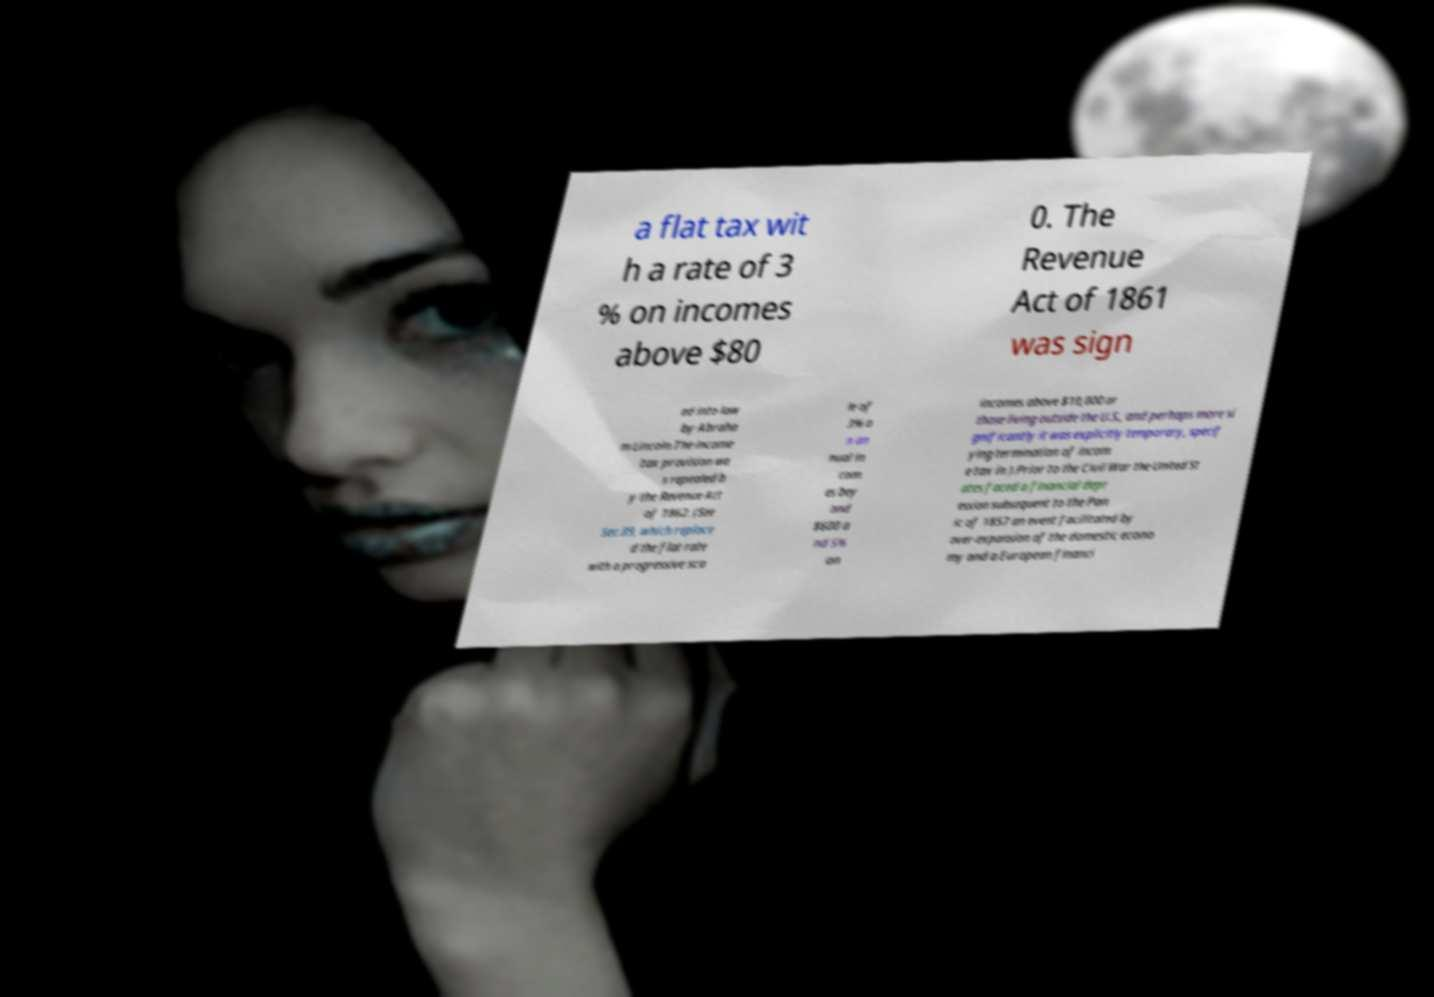Please read and relay the text visible in this image. What does it say? a flat tax wit h a rate of 3 % on incomes above $80 0. The Revenue Act of 1861 was sign ed into law by Abraha m Lincoln.The income tax provision wa s repealed b y the Revenue Act of 1862. (See Sec.89, which replace d the flat rate with a progressive sca le of 3% o n an nual in com es bey ond $600 a nd 5% on incomes above $10,000 or those living outside the U.S., and perhaps more si gnificantly it was explicitly temporary, specif ying termination of incom e tax in ).Prior to the Civil War the United St ates faced a financial depr ession subsequent to the Pan ic of 1857 an event facilitated by over-expansion of the domestic econo my and a European financi 